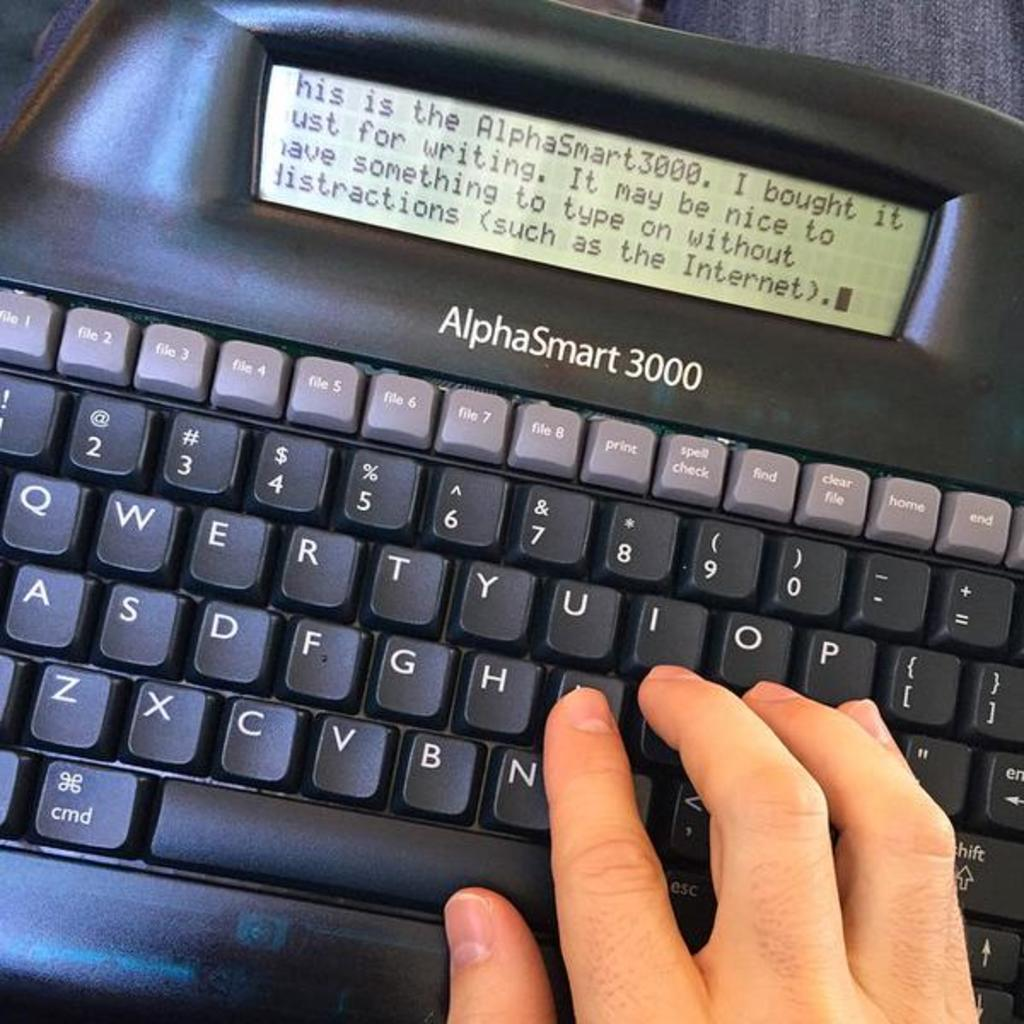<image>
Offer a succinct explanation of the picture presented. An AlphaSmart keyboard has a person typing on it. 